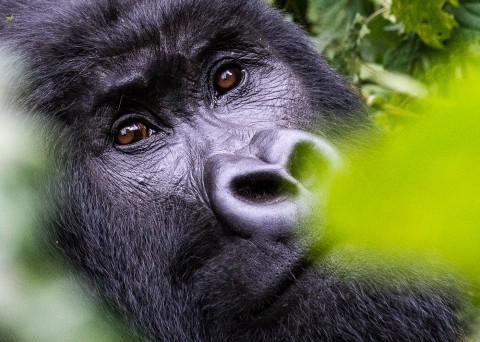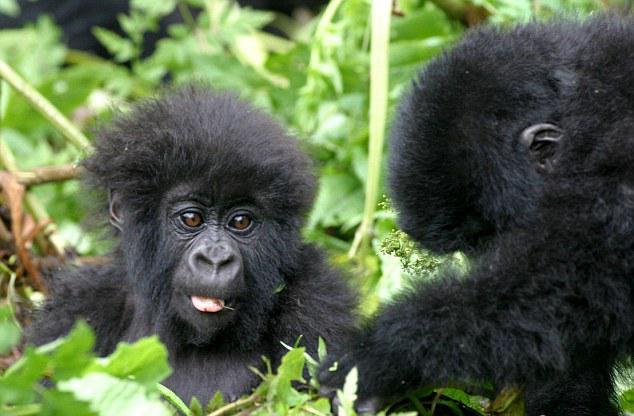The first image is the image on the left, the second image is the image on the right. For the images shown, is this caption "The combined images include exactly two baby gorillas with fuzzy black fur and at least one adult." true? Answer yes or no. Yes. The first image is the image on the left, the second image is the image on the right. Given the left and right images, does the statement "the left and right image contains the same number of gorillas." hold true? Answer yes or no. No. 